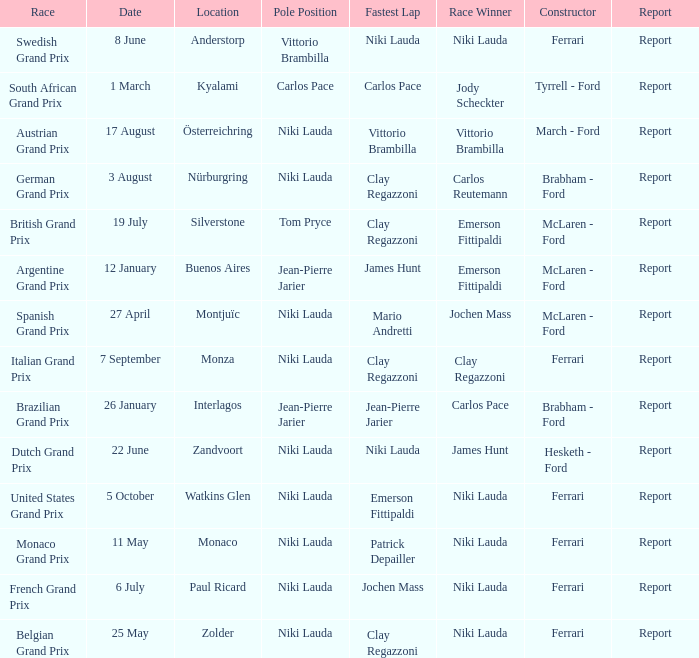Where did the team in which Tom Pryce was in Pole Position race? Silverstone. 